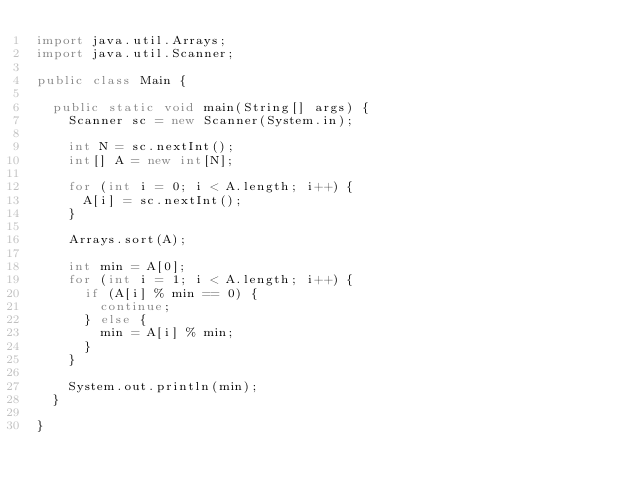<code> <loc_0><loc_0><loc_500><loc_500><_Java_>import java.util.Arrays;
import java.util.Scanner;

public class Main {

	public static void main(String[] args) {
		Scanner sc = new Scanner(System.in);

		int N = sc.nextInt();
		int[] A = new int[N];

		for (int i = 0; i < A.length; i++) {
			A[i] = sc.nextInt();
		}

		Arrays.sort(A);

		int min = A[0];
		for (int i = 1; i < A.length; i++) {
			if (A[i] % min == 0) {
				continue;
			} else {
				min = A[i] % min;
			}
		}

		System.out.println(min);
	}

}</code> 